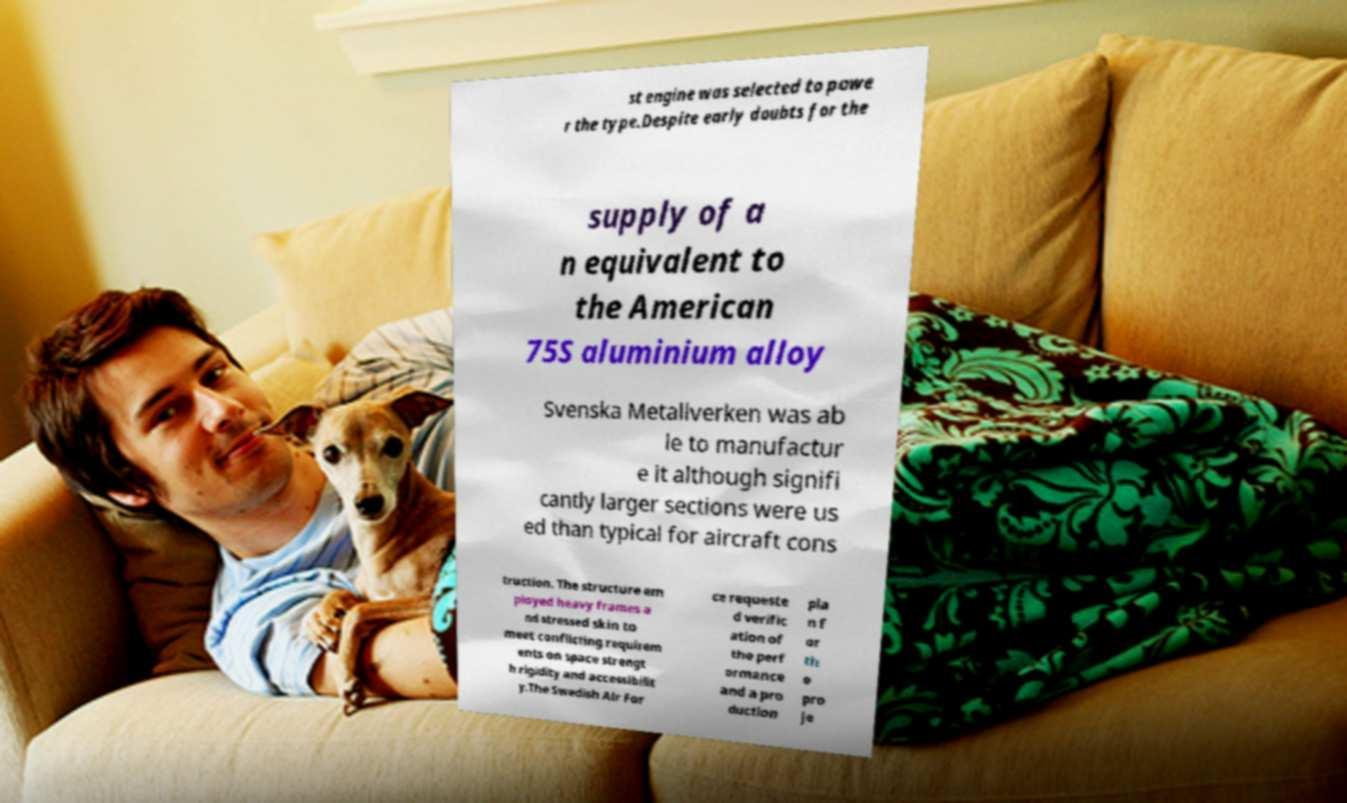Please read and relay the text visible in this image. What does it say? st engine was selected to powe r the type.Despite early doubts for the supply of a n equivalent to the American 75S aluminium alloy Svenska Metallverken was ab le to manufactur e it although signifi cantly larger sections were us ed than typical for aircraft cons truction. The structure em ployed heavy frames a nd stressed skin to meet conflicting requirem ents on space strengt h rigidity and accessibilit y.The Swedish Air For ce requeste d verific ation of the perf ormance and a pro duction pla n f or th e pro je 